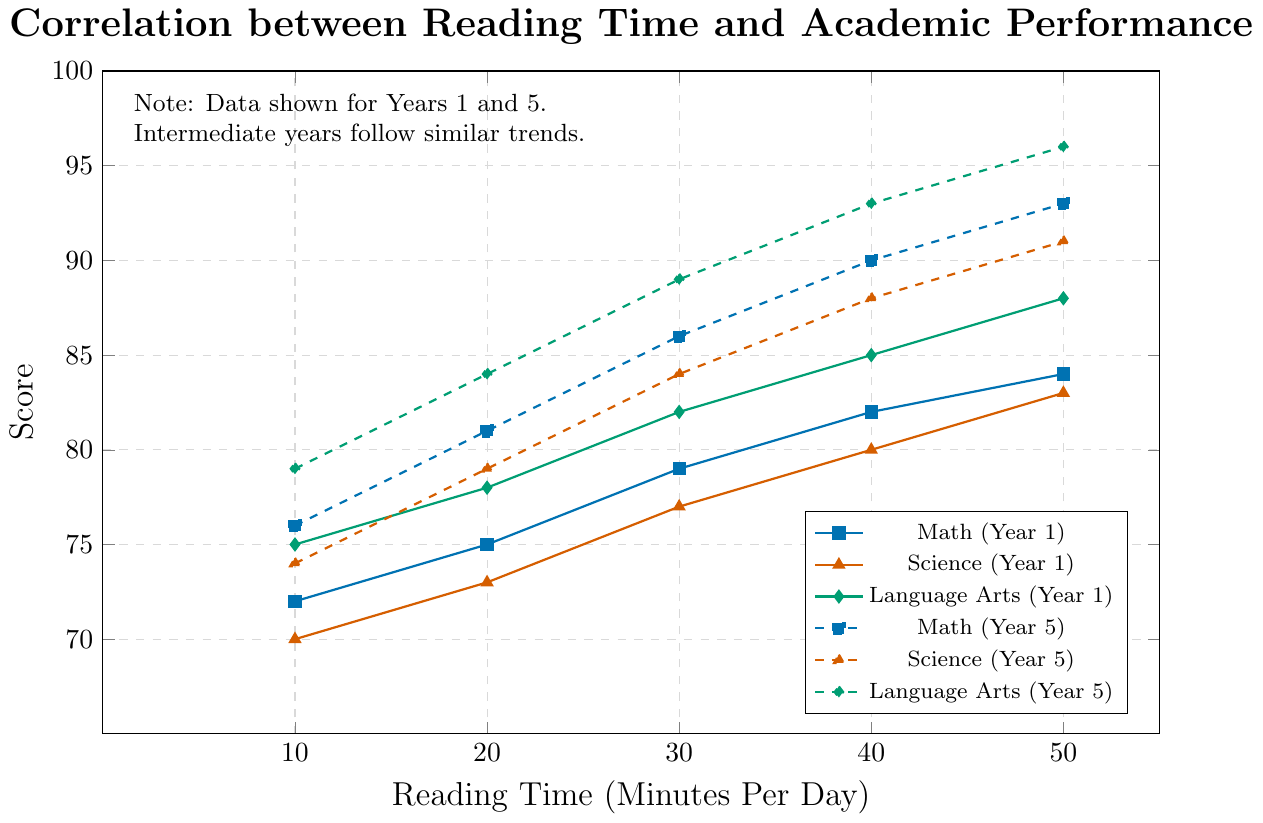What is the Math score for 30 minutes of reading time in Year 1? To find the Math score for 30 minutes of reading in Year 1, look for the point on the line corresponding to Math (Year 1) at Reading Time = 30 minutes.
Answer: 79 What is the difference in Language Arts scores between 50 minutes and 10 minutes of reading time in Year 5? Locate the Language Arts (Year 5) scores for 50 minutes and 10 minutes of reading time, which are 96 and 79 respectively. The difference is calculated as 96 - 79.
Answer: 17 Which Year and subject shows the highest score at any given reading time? Observe the highest peak among all the lines. The highest score is at the point for Language Arts (Year 5) at 50 minutes of reading time.
Answer: Year 5, Language Arts What is the average Math score for 20 minutes of reading time across all years displayed? Sum the Math scores for 20 minutes of reading time across each year (75, 77, 78, 80, 81) and divide by the number of years (5). The average is (75+77+78+80+81)/5.
Answer: 78.2 By how much did the Science score improve from Year 1 to Year 5 at 40 minutes of reading time? Find the Science scores for 40 minutes of reading time in Year 1 (80) and Year 5 (88). The improvement is calculated as 88 - 80.
Answer: 8 What is the correlation trend between reading time and academic performance for Language Arts in Year 1? The Language Arts (Year 1) line shows a continuous increase in scores as reading time increases from 10 minutes to 50 minutes, indicating a positive correlation.
Answer: Positive correlation Which subject has the least improvement in score from 30 minutes to 50 minutes of reading time in Year 1? Compare the score improvements from 30 to 50 minutes for Math (79 to 84), Science (77 to 83), and Language Arts (82 to 88). Calculate the differences: Math (5), Science (6), Language Arts (6). Math has the least improvement.
Answer: Math What color represents the Science scores in Year 5? Identify the color used for the Science (Year 5) line, which is the dashed line with triangle markers. The color used for Science is red.
Answer: Red Which two subjects have nearly the same score increase from 20 to 40 minutes of reading time in Year 5? Calculate the score increases from 20 to 40 minutes for each subject in Year 5: Math (81 to 90, increase of 9), Science (79 to 88, increase of 9), and Language Arts (84 to 93, increase of 9). Math and Science have the same increase.
Answer: Math and Science 